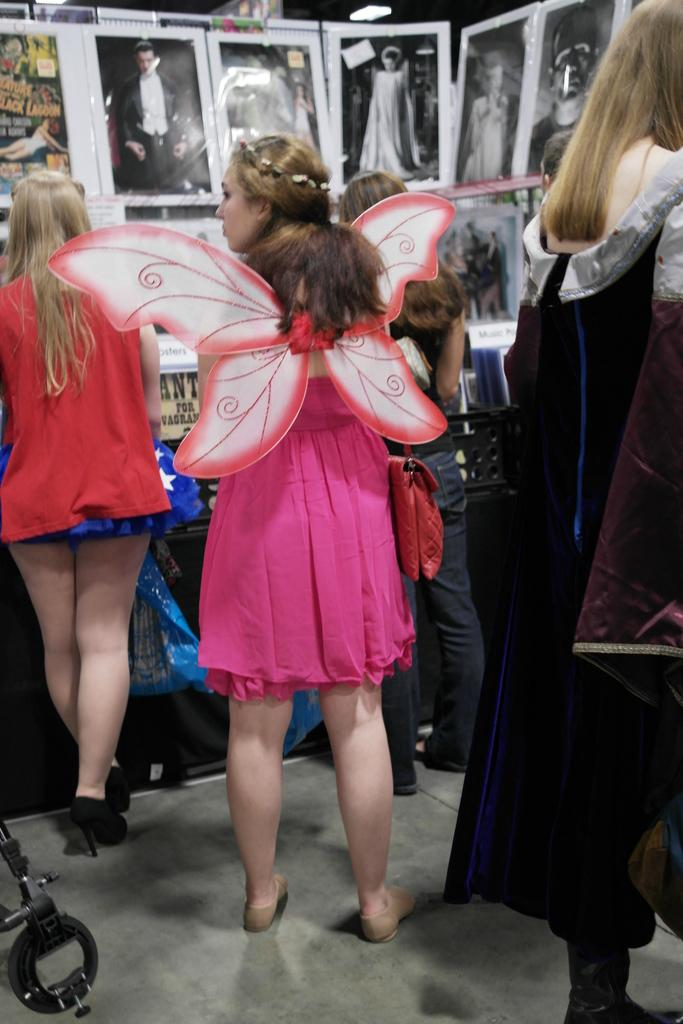What is the main subject of the image? The main subject of the image is a crowd. Where is the crowd located in the image? The crowd is on the floor. What else can be seen in the image besides the crowd? There are photo frames visible in the image. Can you describe the setting of the image? The image is likely taken in a room. How many people are jumping in the image? There is no jumping activity depicted in the image; the crowd is on the floor. What type of beam is supporting the ceiling in the image? There is no beam visible in the image; it is focused on the crowd and photo frames. 